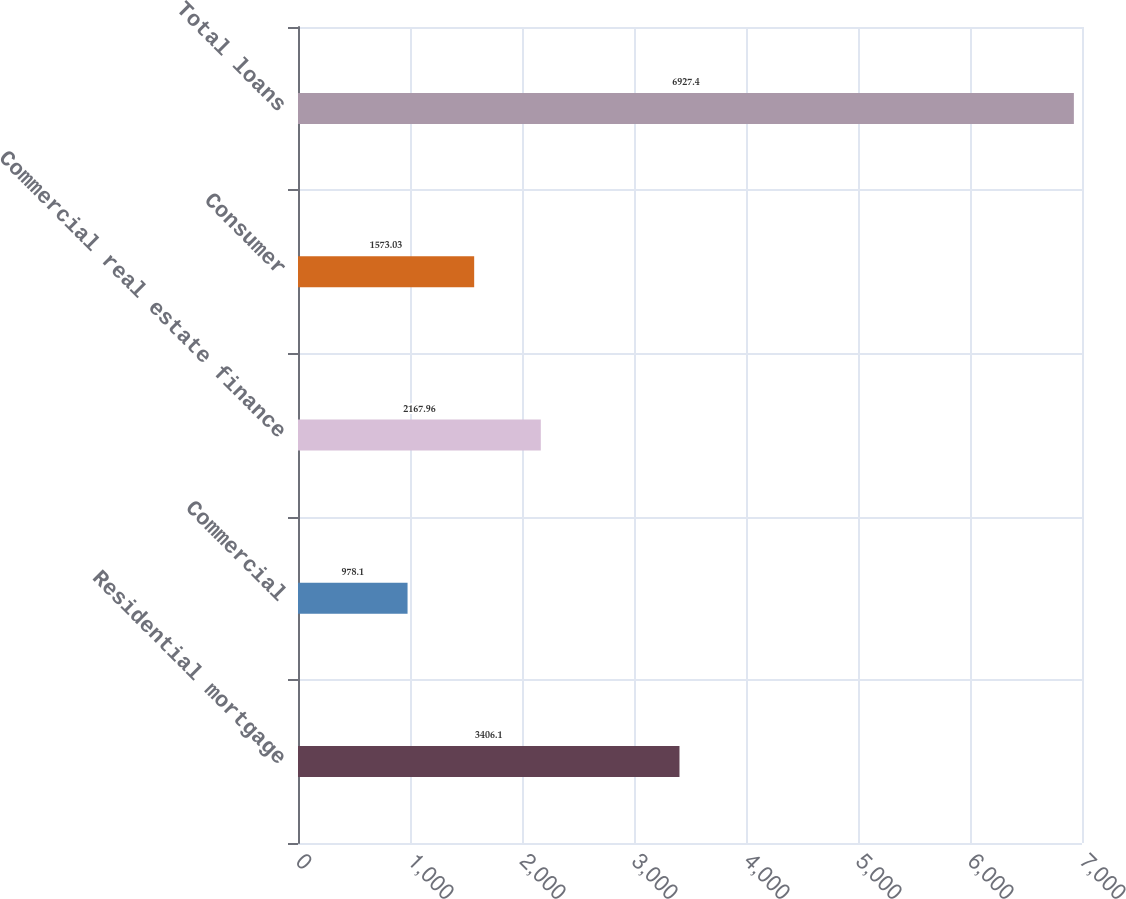Convert chart. <chart><loc_0><loc_0><loc_500><loc_500><bar_chart><fcel>Residential mortgage<fcel>Commercial<fcel>Commercial real estate finance<fcel>Consumer<fcel>Total loans<nl><fcel>3406.1<fcel>978.1<fcel>2167.96<fcel>1573.03<fcel>6927.4<nl></chart> 